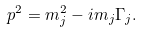<formula> <loc_0><loc_0><loc_500><loc_500>p ^ { 2 } = m _ { j } ^ { 2 } - i m _ { j } \Gamma _ { j } .</formula> 